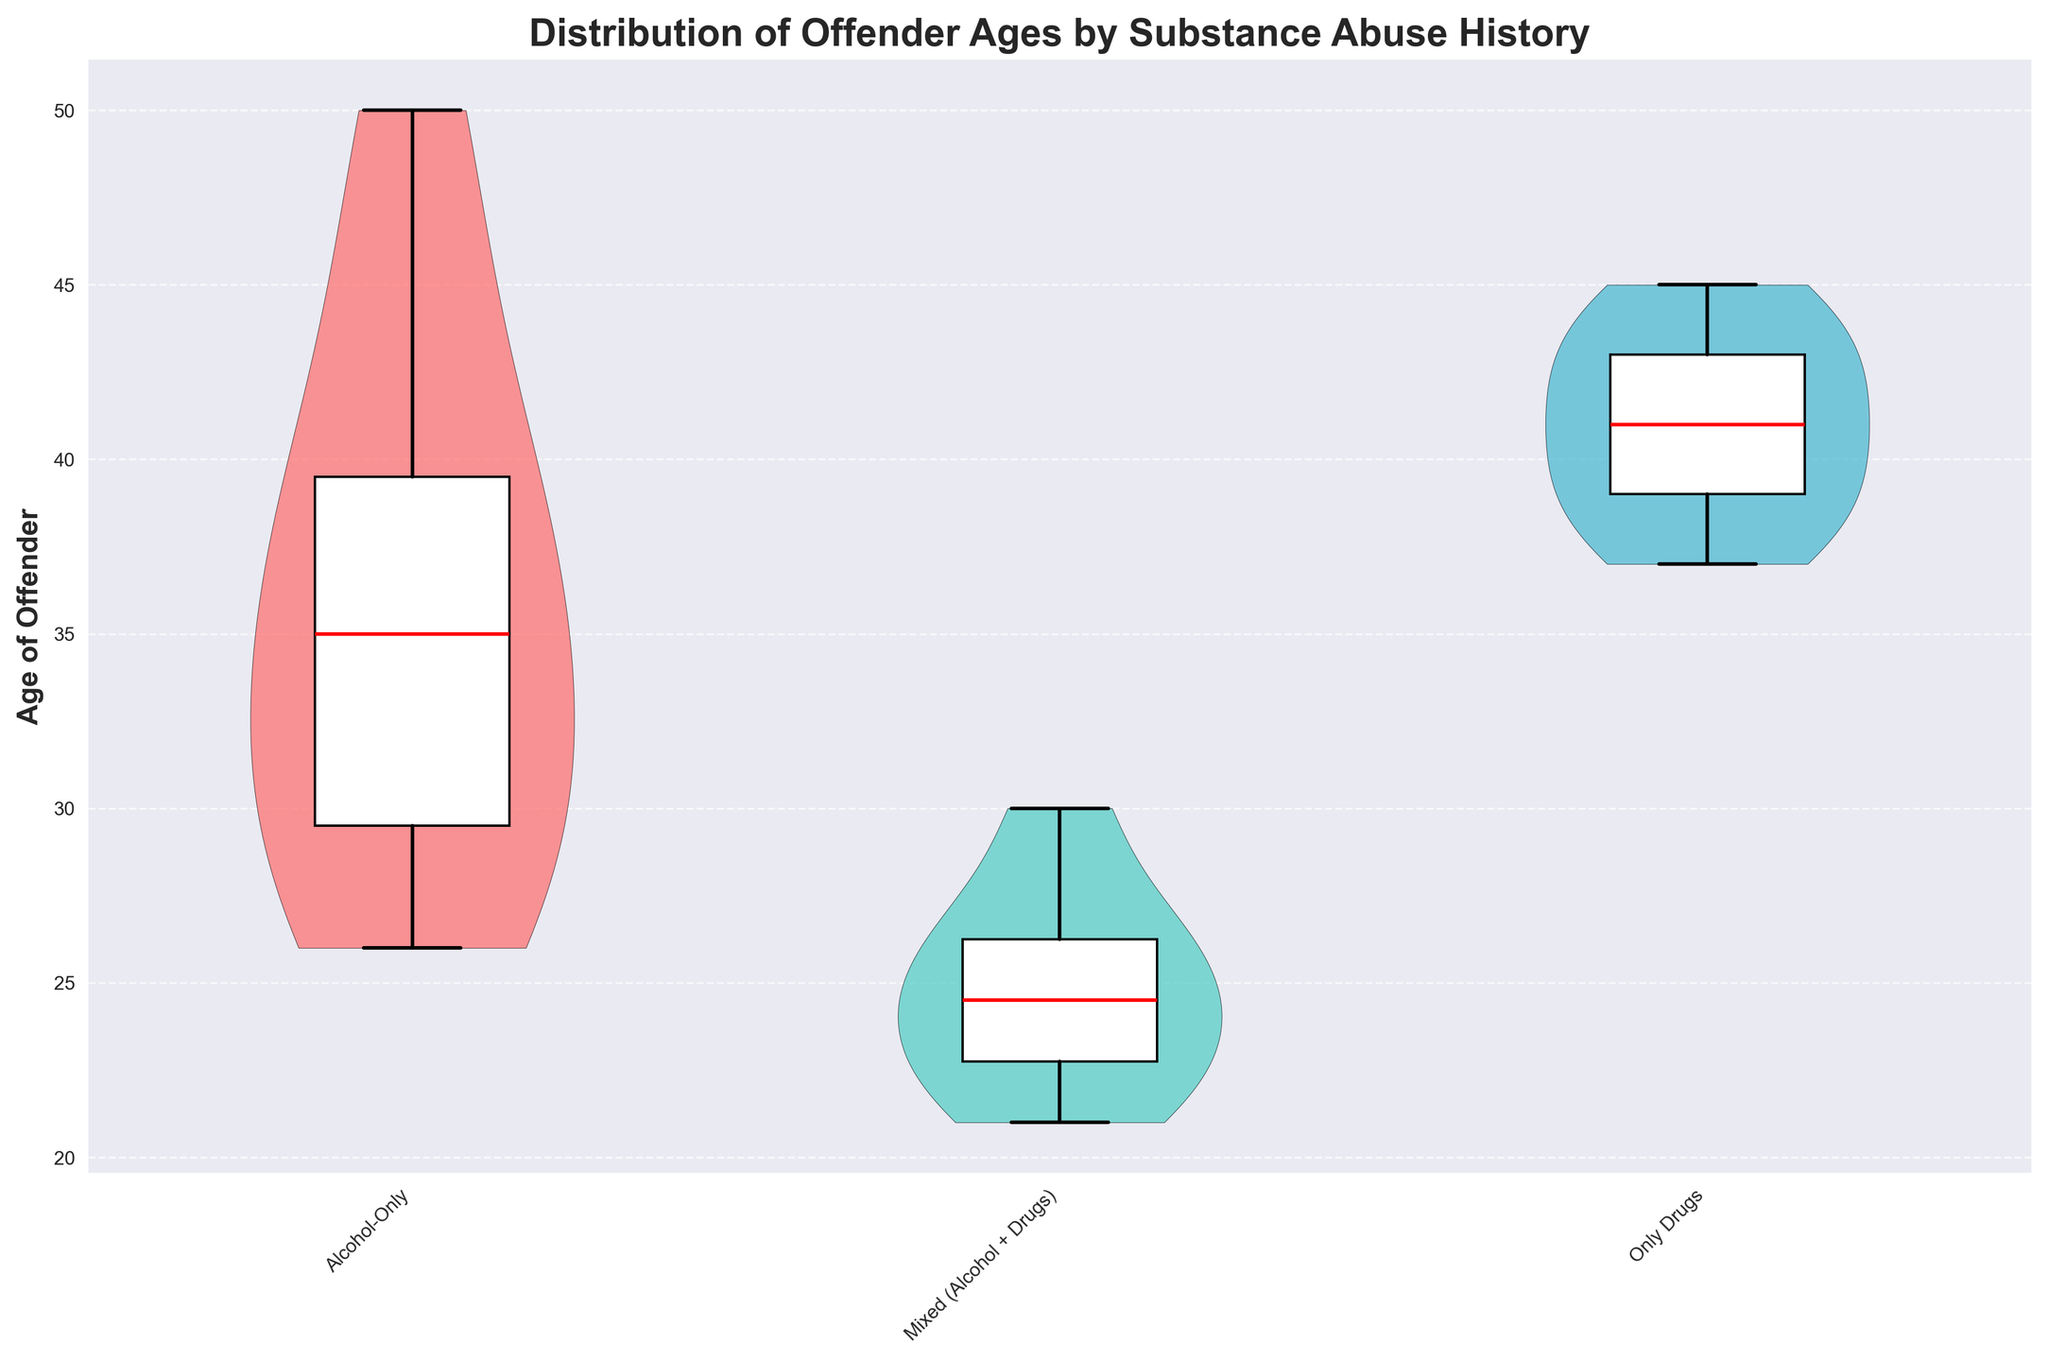what is the title of the figure? The title of the figure is displayed at the top. It summarizes the main purpose of the chart.
Answer: Distribution of Offender Ages by Substance Abuse History What is the median age of offenders with only drug abuse history? The median age for offenders with only drug abuse history can be identified by locating the red median line within the boxplot corresponding to the "Only Drugs" category on the x-axis.
Answer: 41 Which substance abuse history group has the narrowest range of offender ages? To find the group with the narrowest range, examine the length of the box plot whiskers for each category on the x-axis. The group with the shortest whiskers has the narrowest range. The "Mixed (Alcohol + Drugs)" group shows the narrowest age range.
Answer: Mixed (Alcohol + Drugs) Among "_Alcohol-Only_", which age group contains the most data points? Violin plots show density information. The area around the 30-35 age range in the "Alcohol-Only" violin plot is the widest, indicating the highest density of data points.
Answer: 30-35 How does the variability of offender ages compare between "Alcohol-Only" and "Only Drugs" groups? Variability in age can be observed by comparing the width and spread of the violin plots and the length of the whiskers in the box plots for both groups. "Alcohol-Only" shows a slightly narrower spread compared to "Only Drugs", indicating less variability.
Answer: Only Drugs shows higher variability What is the mode age range of offenders in the "Domestic" type of homicide? Since the "Domestic" homicide type is linked with "Alcohol-Only" in the data, the mode age range—where the violin plot is widest—appears around the 30-35 age range.
Answer: 30-35 Which group shows a higher median age: "Mixed (Alcohol + Drugs)" or "Alcohol-Only"? Compare the position of the red median lines of the boxplots for "Mixed (Alcohol + Drugs)" and "Alcohol-Only" groups. "Alcohol-Only" has a higher median age.
Answer: Alcohol-Only Is the distribution of offender ages in the "Only Drugs" category skewed? If so, in which direction? Skewness in the violins plot can be assessed by the asymmetry of the plot. The "Only Drugs" violin plot shows a slight right skew due to a longer tail on the older age side.
Answer: Slightly right-skewed Compare the interquartile range (IQR) of the "Mixed (Alcohol + Drugs)" group with the "Only Drugs" group. The IQR is the length of the box in the boxplot. By comparing the lengths, it is evident that the "Mixed (Alcohol + Drugs)" group has a much smaller IQR than the "Only Drugs" group.
Answer: Mixed (Alcohol + Drugs) has a smaller IQR What age range is covered by the lower whisker of the "Alcohol-Only" group? The lower whisker of the "Alcohol-Only" boxplot extends to the lowest age value within 1.5 times the interquartile range below the lower quartile. This range starts from about age 26.
Answer: Around 26 